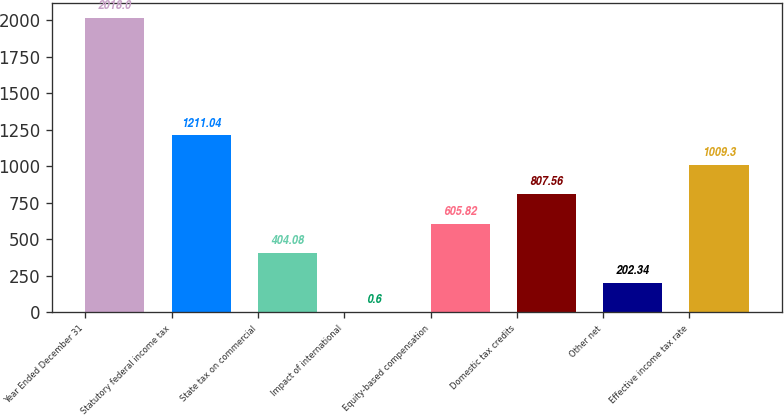Convert chart. <chart><loc_0><loc_0><loc_500><loc_500><bar_chart><fcel>Year Ended December 31<fcel>Statutory federal income tax<fcel>State tax on commercial<fcel>Impact of international<fcel>Equity-based compensation<fcel>Domestic tax credits<fcel>Other net<fcel>Effective income tax rate<nl><fcel>2018<fcel>1211.04<fcel>404.08<fcel>0.6<fcel>605.82<fcel>807.56<fcel>202.34<fcel>1009.3<nl></chart> 